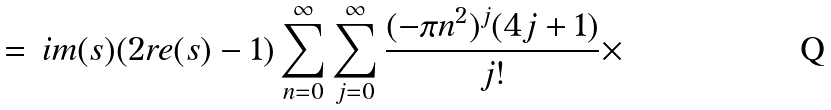<formula> <loc_0><loc_0><loc_500><loc_500>\, = \, i m ( s ) ( 2 r e ( s ) - 1 ) \sum _ { n = 0 } ^ { \infty } \sum _ { j = 0 } ^ { \infty } \frac { ( - \pi n ^ { 2 } ) ^ { j } ( 4 j + 1 ) } { j ! } \times</formula> 